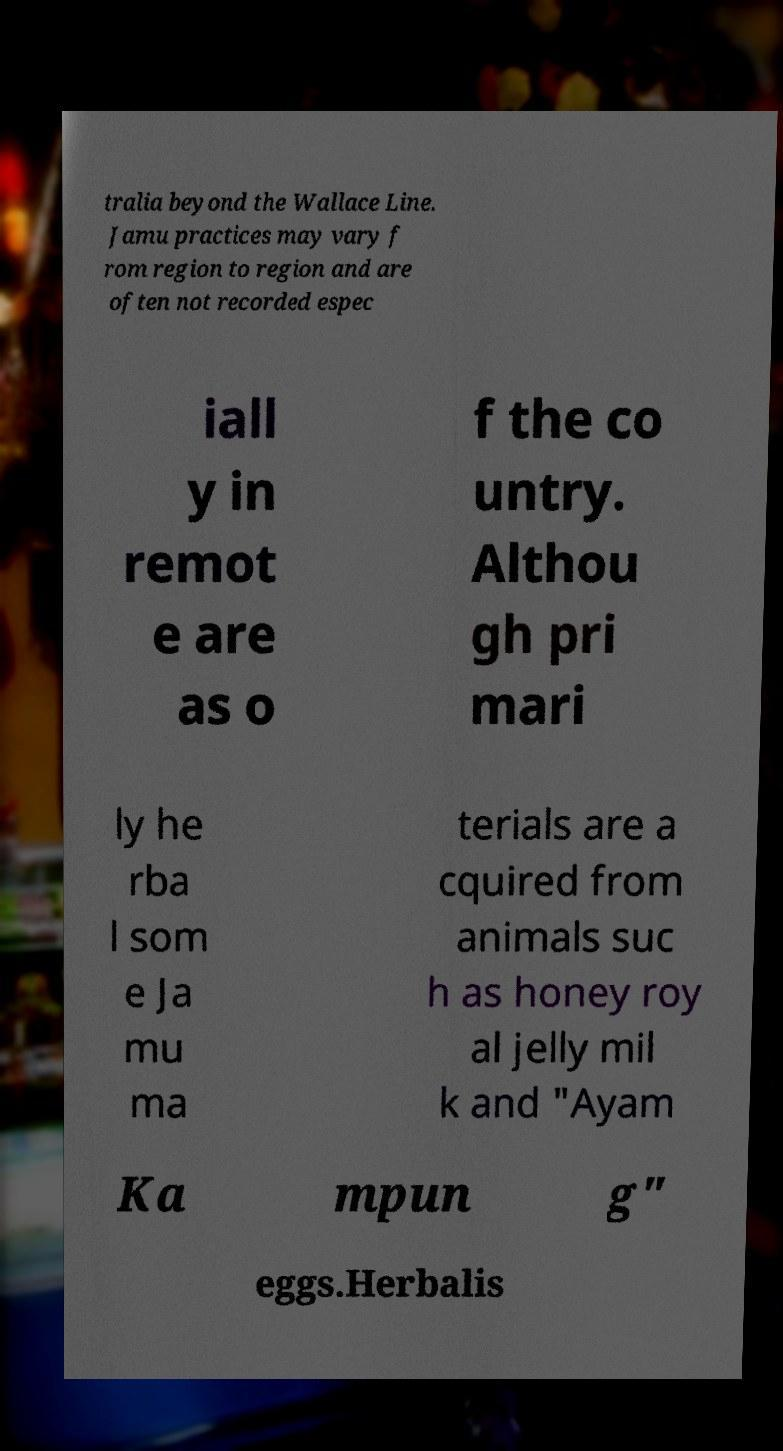Could you assist in decoding the text presented in this image and type it out clearly? tralia beyond the Wallace Line. Jamu practices may vary f rom region to region and are often not recorded espec iall y in remot e are as o f the co untry. Althou gh pri mari ly he rba l som e Ja mu ma terials are a cquired from animals suc h as honey roy al jelly mil k and "Ayam Ka mpun g" eggs.Herbalis 